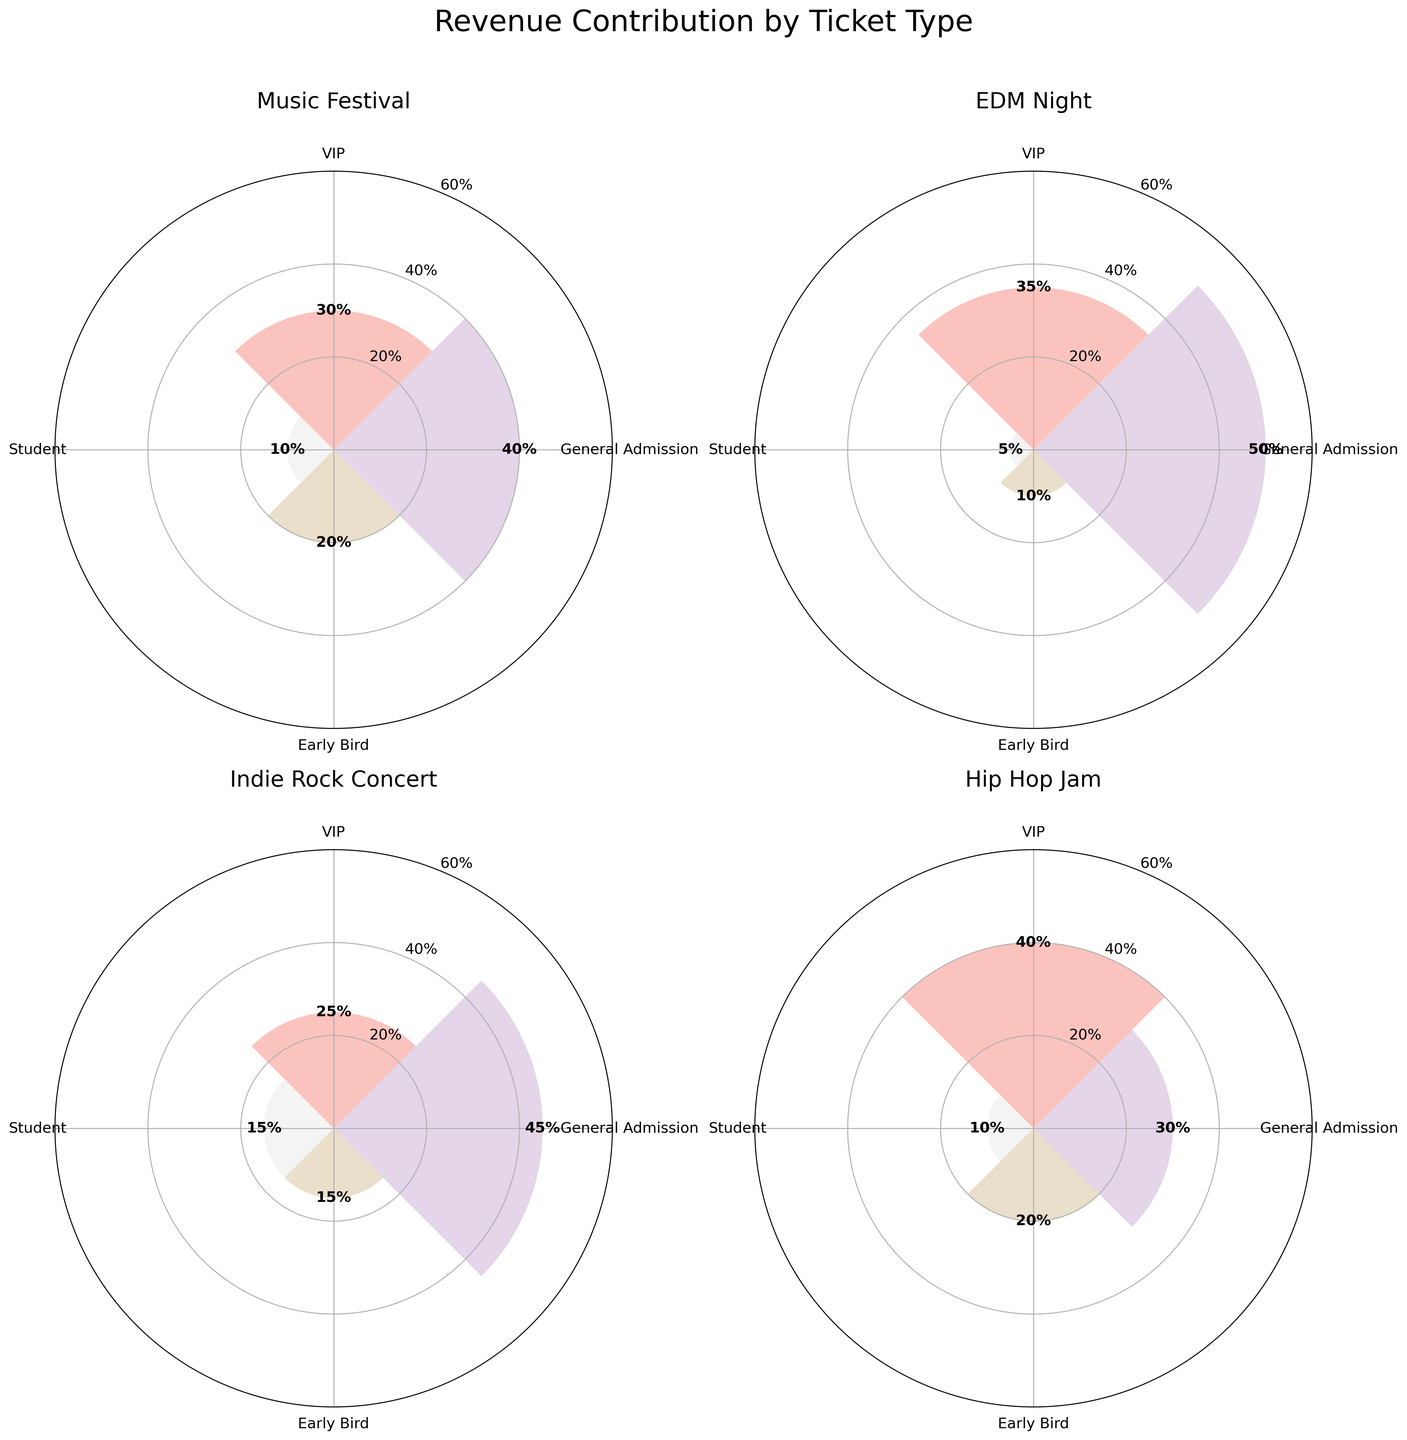what is the title of the figure? The title of a figure is located at the top and gives a summary of what the figure depicts. In this case, the title "Revenue Contribution by Ticket Type" is clearly labeled at the top.
Answer: Revenue Contribution by Ticket Type which event has the highest revenue contribution from VIP tickets? Locate the segment labeled "VIP" in each subplot and compare the heights of the bars. The highest bar among the VIP segments is for "Hip Hop Jam," at 40%.
Answer: Hip Hop Jam what is the revenue contribution from General Admission tickets in EDM Night? Find the subplot for "EDM Night" and identify the bar labeled "General Admission." The height labeled on the bar is 50%.
Answer: 50% what is the sum of revenue contributions from Early Bird and Student tickets in the Indie Rock Concert? Locate the subplot for "Indie Rock Concert" and identify the bars for "Early Bird" (15%) and "Student" (15%). Add these values together (15% + 15% = 30%).
Answer: 30% which event has the lowest revenue contribution from Student tickets? Compare the heights of the bars labeled "Student" across all subplots. The smallest bar is in the "EDM Night" subplot, at 5%.
Answer: EDM Night in which event do General Admission tickets contribute more revenue than VIP tickets? Compare the heights of the "General Admission" and "VIP" bars in each subplot. The "Music Festival" (General Admission 40% vs. VIP 30%) and "Indie Rock Concert" (General Admission 45% vs. VIP 25%) meet this criterion.
Answer: Music Festival, Indie Rock Concert how does the revenue contribution from Student tickets in EDM Night compare to that in Hip Hop Jam? Look at the "Student" bars in both subplots. "EDM Night" has a 5% contribution, and "Hip Hop Jam" has a 10% contribution. So, Hip Hop Jam has higher student revenue.
Answer: Hip Hop Jam has a higher contribution what is the average revenue contribution from VIP tickets across all events? Locate the "VIP" bars across all subplots: Music Festival (30%), EDM Night (35%), Indie Rock Concert (25%), Hip Hop Jam (40%). Calculate the average: (30% + 35% + 25% + 40%) / 4 = 32.5%.
Answer: 32.5% which event's Early Bird tickets contribute the most to revenue? Compare the heights of the "Early Bird" bars in all subplots. Both "Music Festival" and "Hip Hop Jam" have Early Bird contributions of 20%.
Answer: Music Festival, Hip Hop Jam 